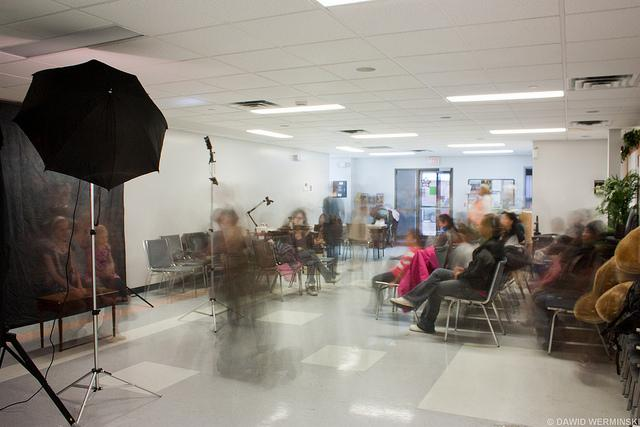What is the umbrella being used for? lighting 